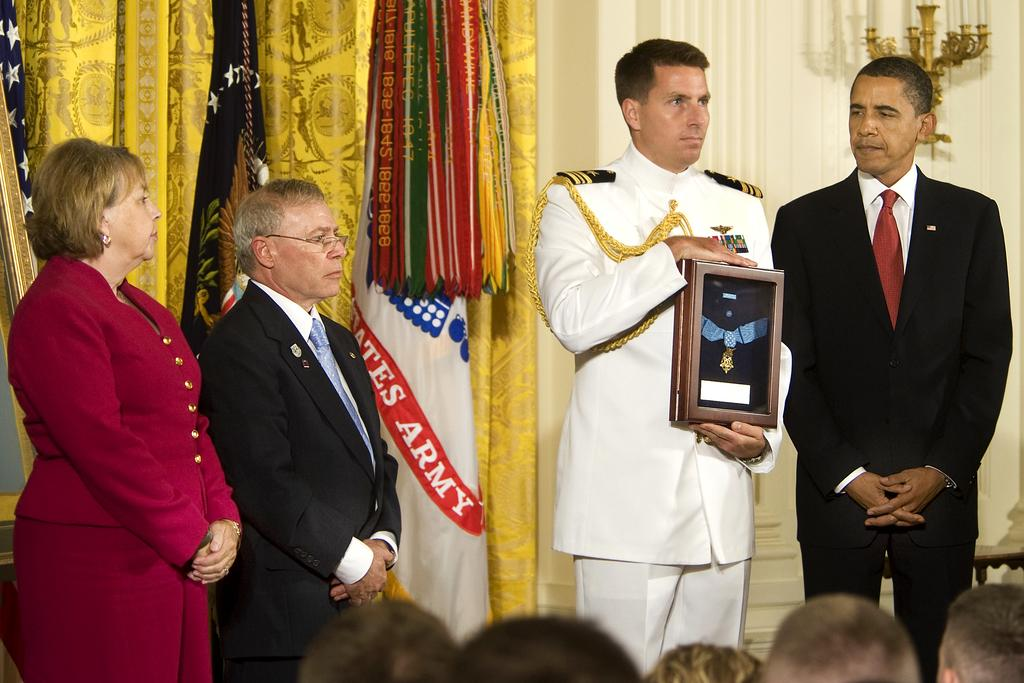<image>
Present a compact description of the photo's key features. Military man receiving a medal in front of a flag with a red stripe that has Army on it. 